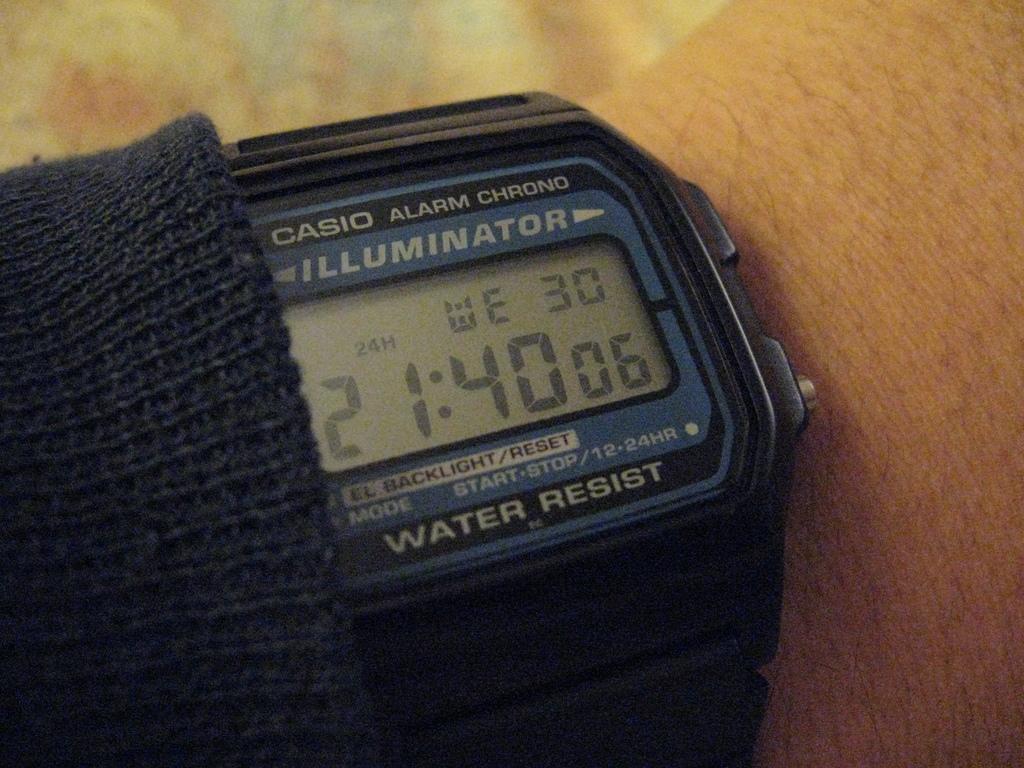What casio watch is this?
Offer a terse response. Illuminator. What does this watch resist?
Your response must be concise. Water. 